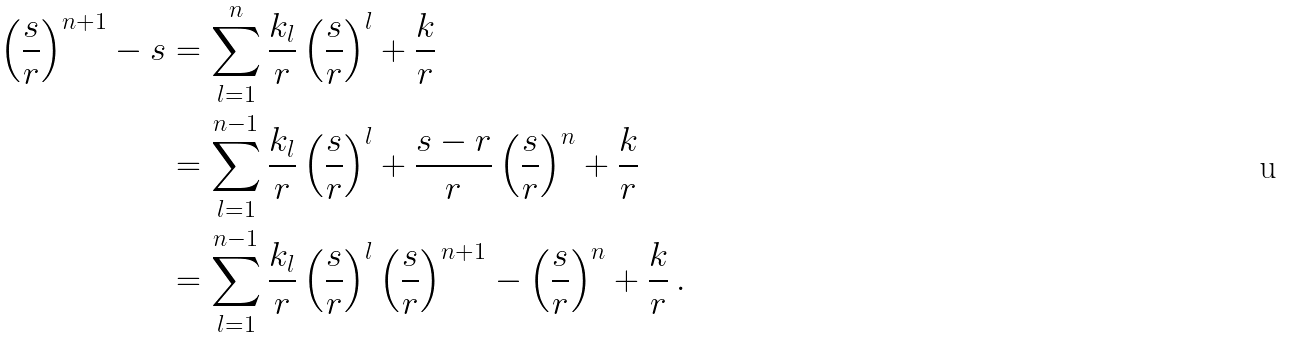Convert formula to latex. <formula><loc_0><loc_0><loc_500><loc_500>\left ( \frac { s } { r } \right ) ^ { n + 1 } - s & = \sum _ { l = 1 } ^ { n } \frac { k _ { l } } { r } \left ( \frac { s } { r } \right ) ^ { l } + \frac { k } { r } \\ & = \sum _ { l = 1 } ^ { n - 1 } \frac { k _ { l } } { r } \left ( \frac { s } { r } \right ) ^ { l } + \frac { s - r } { r } \left ( \frac { s } { r } \right ) ^ { n } + \frac { k } { r } \\ & = \sum _ { l = 1 } ^ { n - 1 } \frac { k _ { l } } { r } \left ( \frac { s } { r } \right ) ^ { l } \left ( \frac { s } { r } \right ) ^ { n + 1 } - \left ( \frac { s } { r } \right ) ^ { n } + \frac { k } { r } \, .</formula> 